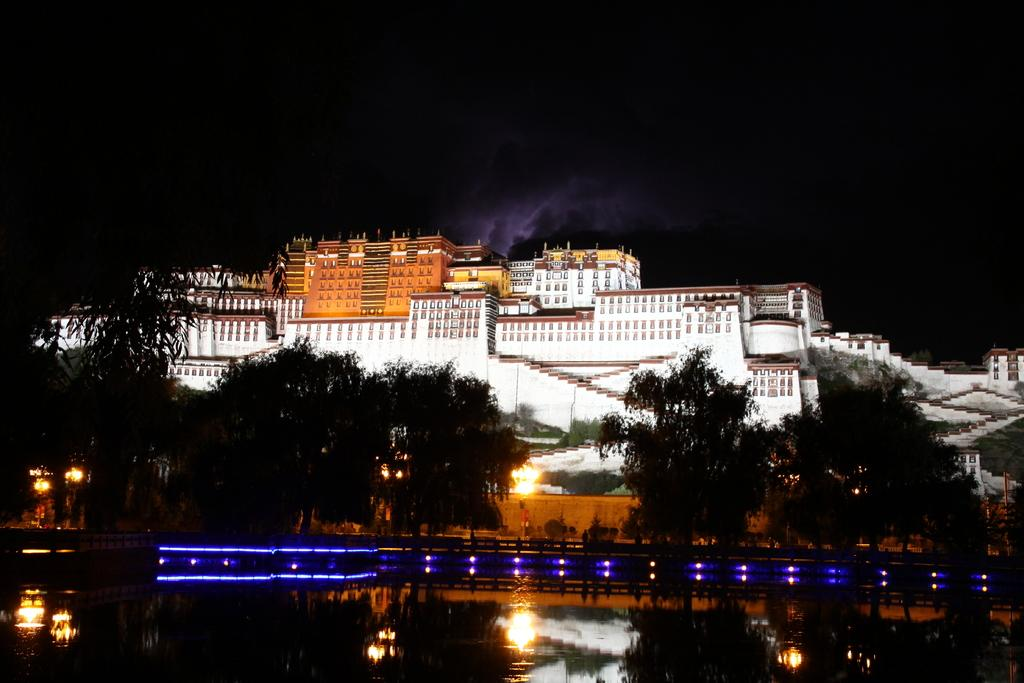What type of structures can be seen in the image? There is a group of buildings in the image. What other natural elements are present in the image? There are trees and a water body in the image. What type of barrier is visible in the image? There is a fence in the image. What can be used for illumination in the image? There are lights in the image. What part of the natural environment is visible in the image? The sky is visible in the image. What type of tooth is visible in the image? There is no tooth present in the image. What discovery was made in the image? There is no discovery mentioned or depicted in the image. 